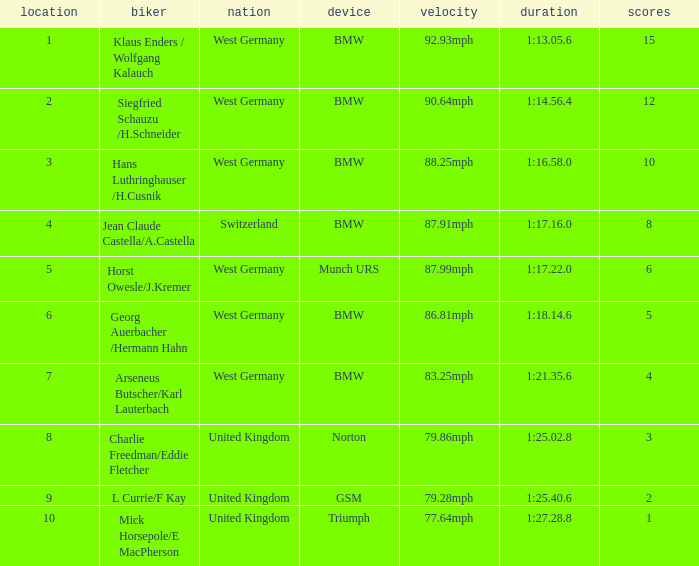Which places have points larger than 10? None. 